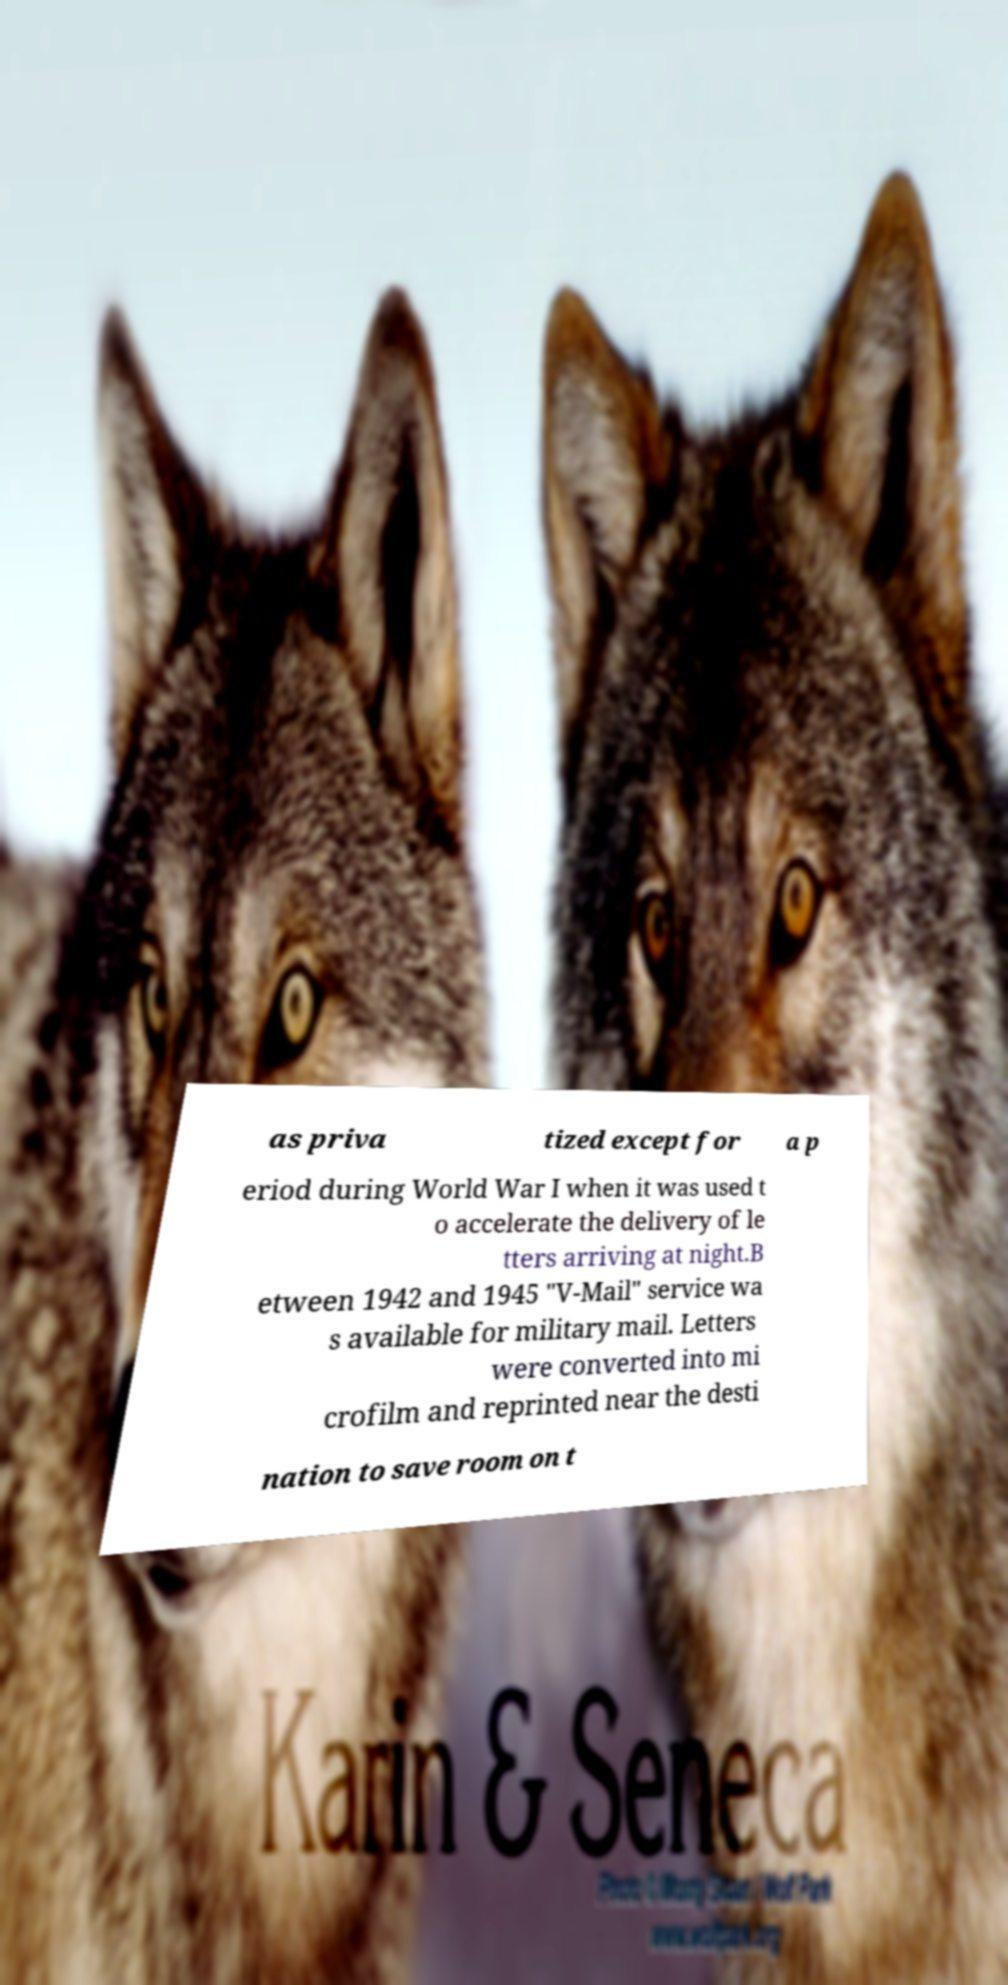For documentation purposes, I need the text within this image transcribed. Could you provide that? as priva tized except for a p eriod during World War I when it was used t o accelerate the delivery of le tters arriving at night.B etween 1942 and 1945 "V-Mail" service wa s available for military mail. Letters were converted into mi crofilm and reprinted near the desti nation to save room on t 